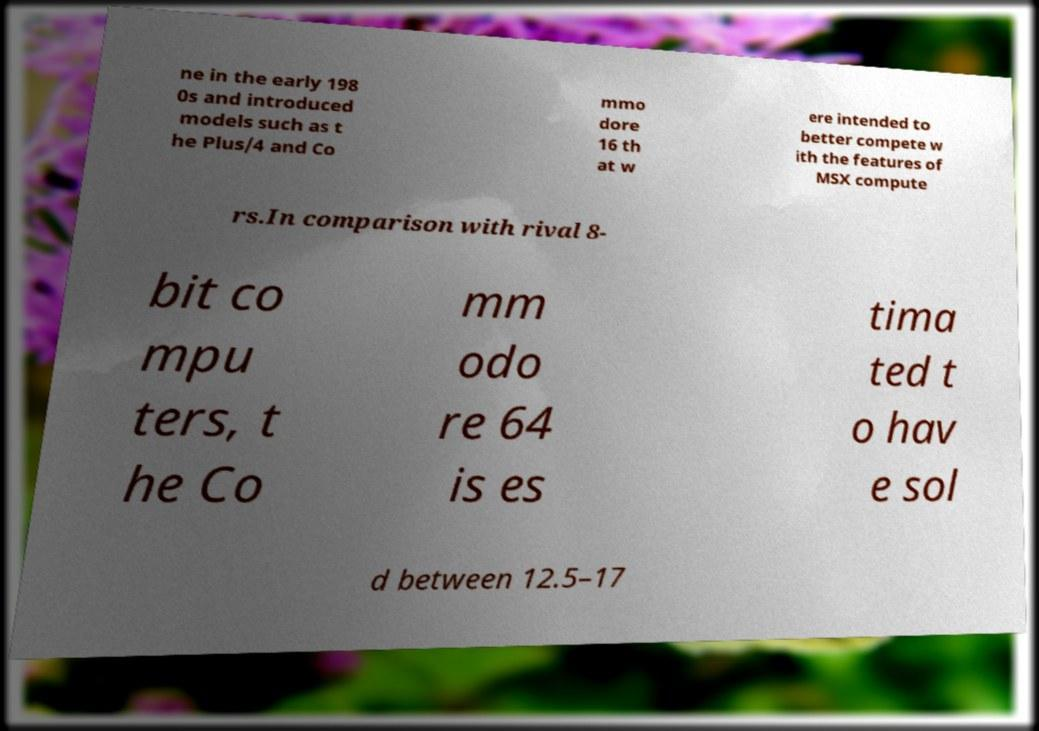I need the written content from this picture converted into text. Can you do that? ne in the early 198 0s and introduced models such as t he Plus/4 and Co mmo dore 16 th at w ere intended to better compete w ith the features of MSX compute rs.In comparison with rival 8- bit co mpu ters, t he Co mm odo re 64 is es tima ted t o hav e sol d between 12.5–17 